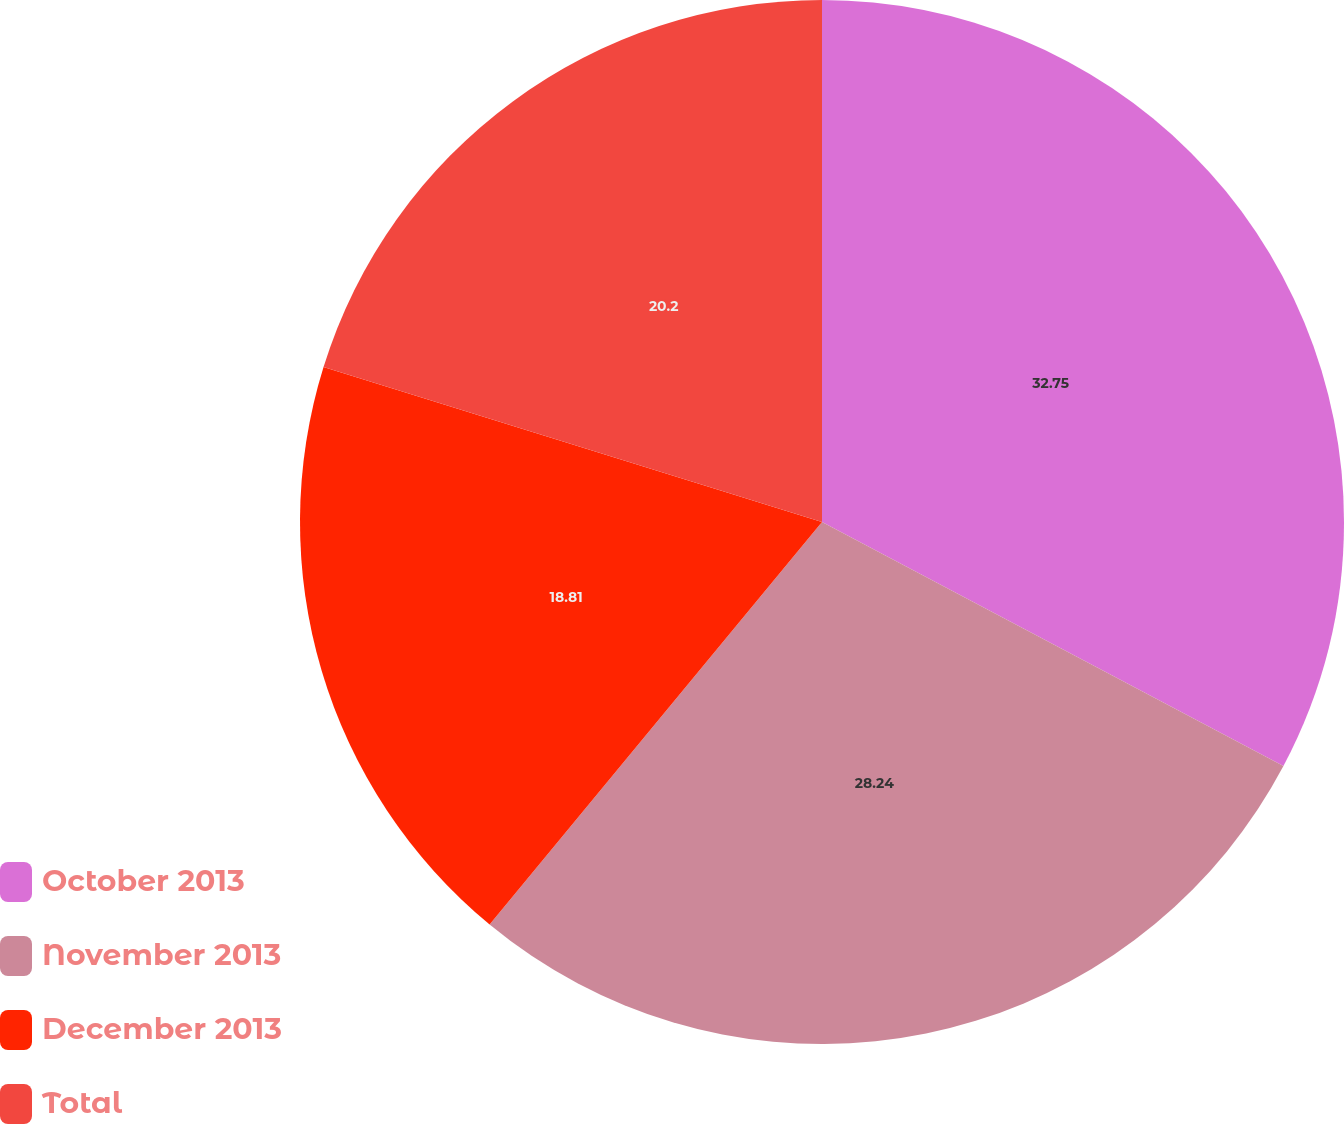<chart> <loc_0><loc_0><loc_500><loc_500><pie_chart><fcel>October 2013<fcel>November 2013<fcel>December 2013<fcel>Total<nl><fcel>32.74%<fcel>28.24%<fcel>18.81%<fcel>20.2%<nl></chart> 